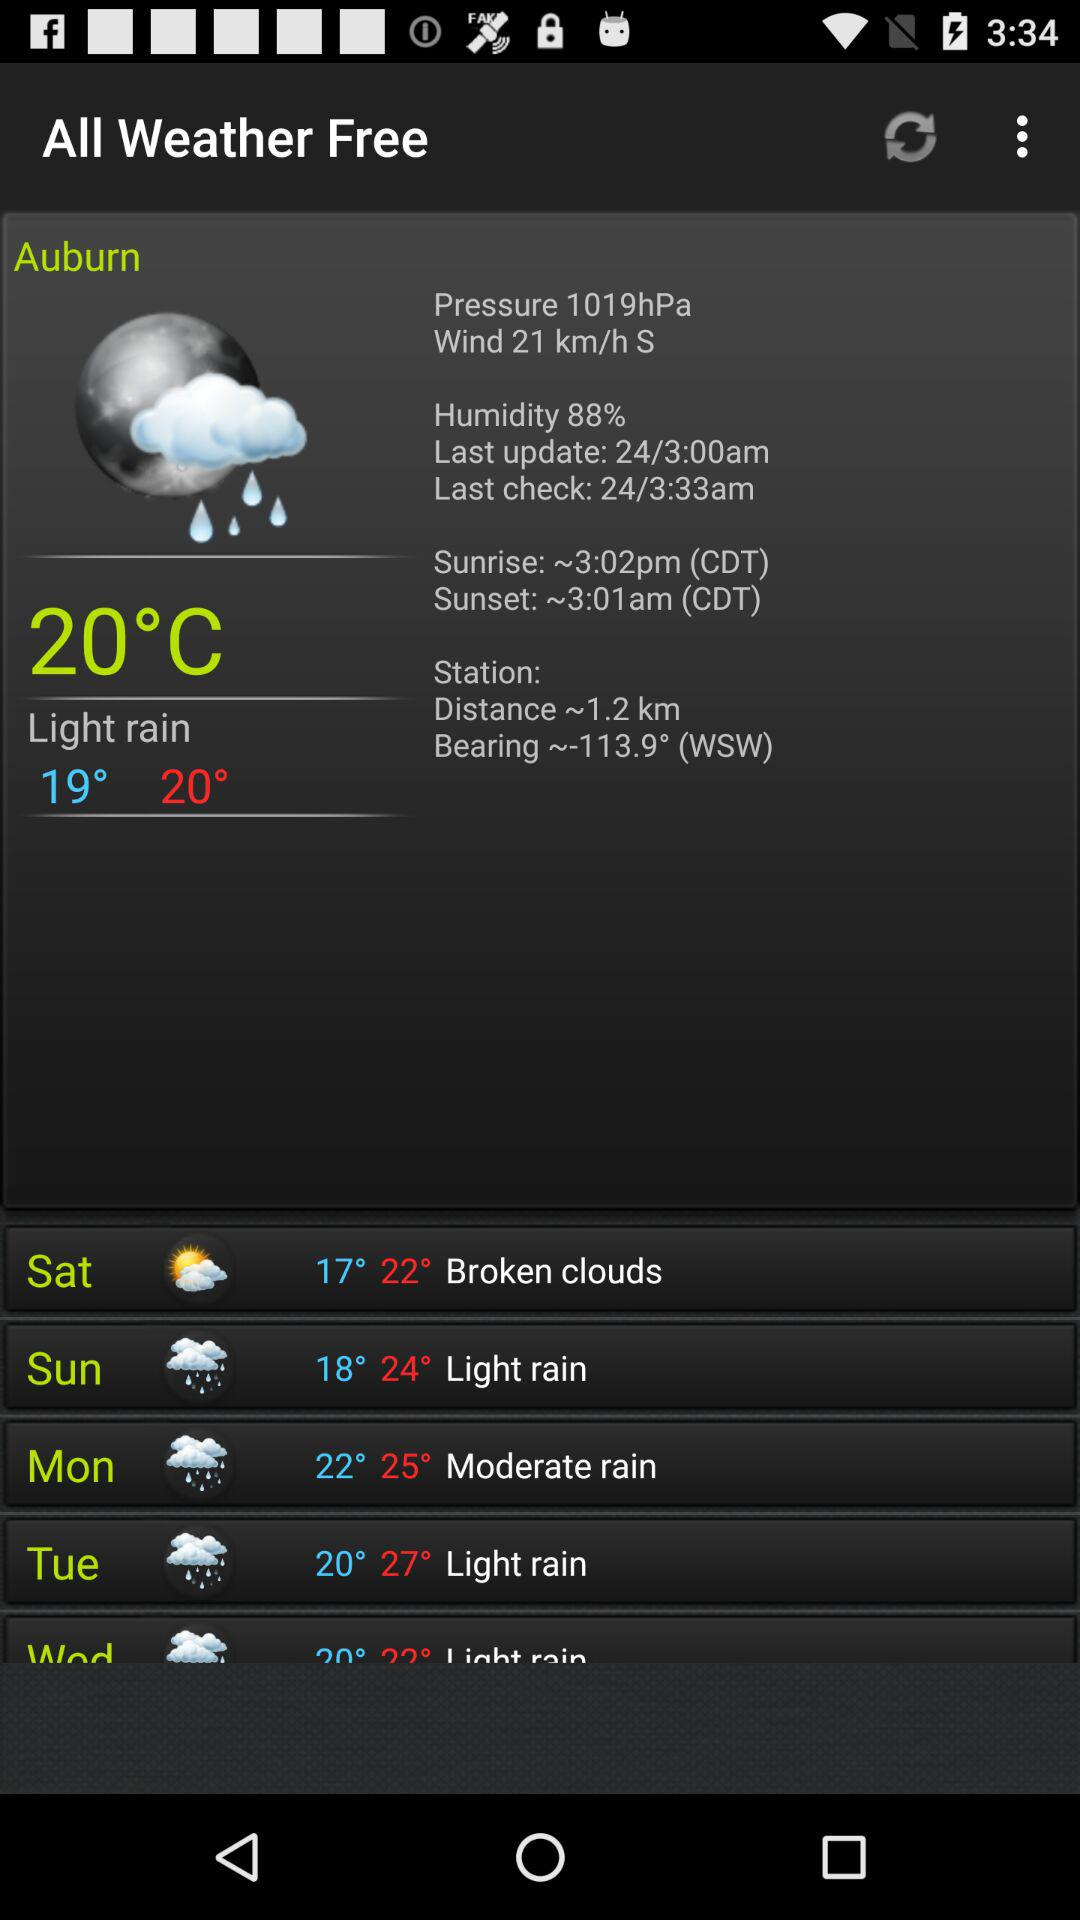What is the weather on Sunday? The weather on Sunday is "Light rain". 